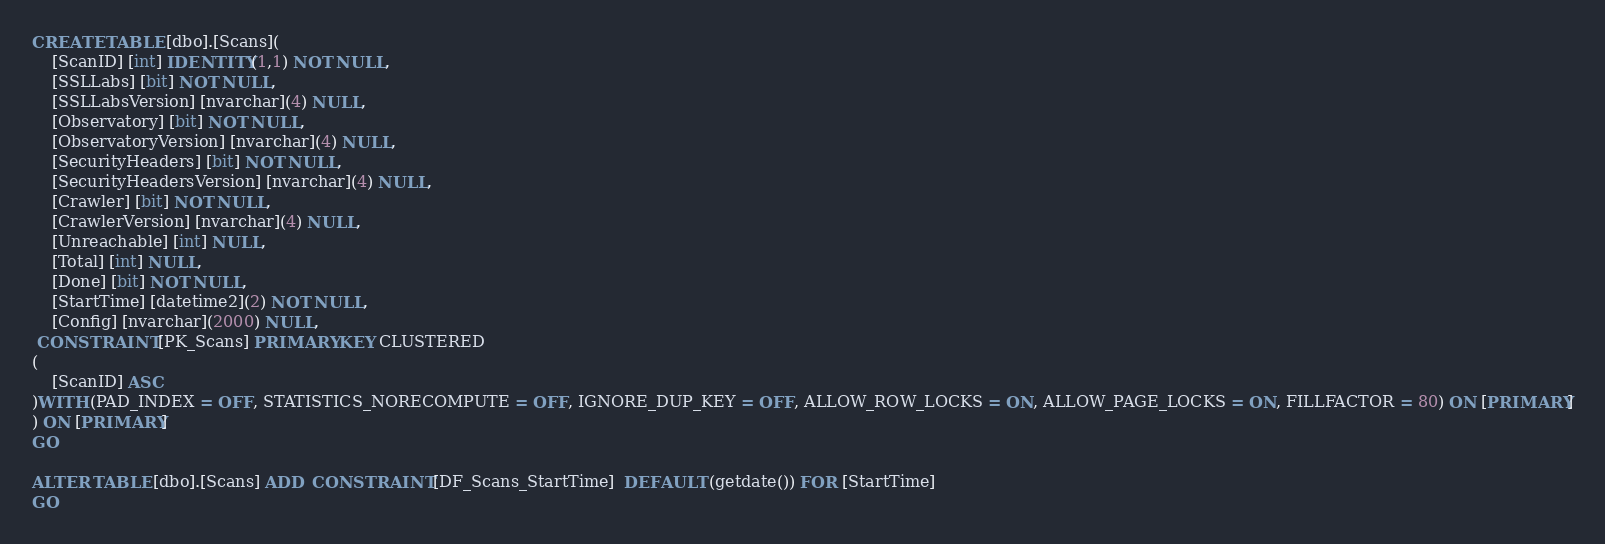Convert code to text. <code><loc_0><loc_0><loc_500><loc_500><_SQL_>CREATE TABLE [dbo].[Scans](
	[ScanID] [int] IDENTITY(1,1) NOT NULL,
	[SSLLabs] [bit] NOT NULL,
	[SSLLabsVersion] [nvarchar](4) NULL,
	[Observatory] [bit] NOT NULL,
	[ObservatoryVersion] [nvarchar](4) NULL,
	[SecurityHeaders] [bit] NOT NULL,
	[SecurityHeadersVersion] [nvarchar](4) NULL,
	[Crawler] [bit] NOT NULL,
	[CrawlerVersion] [nvarchar](4) NULL,
	[Unreachable] [int] NULL,
	[Total] [int] NULL,
	[Done] [bit] NOT NULL,
	[StartTime] [datetime2](2) NOT NULL,
	[Config] [nvarchar](2000) NULL,
 CONSTRAINT [PK_Scans] PRIMARY KEY CLUSTERED 
(
	[ScanID] ASC
)WITH (PAD_INDEX = OFF, STATISTICS_NORECOMPUTE = OFF, IGNORE_DUP_KEY = OFF, ALLOW_ROW_LOCKS = ON, ALLOW_PAGE_LOCKS = ON, FILLFACTOR = 80) ON [PRIMARY]
) ON [PRIMARY]
GO

ALTER TABLE [dbo].[Scans] ADD  CONSTRAINT [DF_Scans_StartTime]  DEFAULT (getdate()) FOR [StartTime]
GO


</code> 